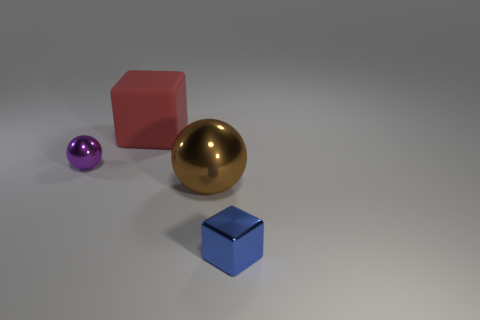Add 2 small gray objects. How many objects exist? 6 Subtract all red blocks. How many blocks are left? 1 Subtract all tiny purple rubber objects. Subtract all brown metal things. How many objects are left? 3 Add 4 big things. How many big things are left? 6 Add 2 big red rubber objects. How many big red rubber objects exist? 3 Subtract 0 blue cylinders. How many objects are left? 4 Subtract all brown spheres. Subtract all red cylinders. How many spheres are left? 1 